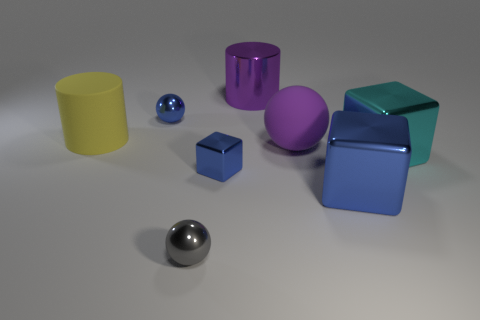Add 2 rubber things. How many objects exist? 10 Subtract all cubes. How many objects are left? 5 Subtract all large cyan rubber balls. Subtract all tiny gray metallic spheres. How many objects are left? 7 Add 2 metal spheres. How many metal spheres are left? 4 Add 8 large cyan matte cylinders. How many large cyan matte cylinders exist? 8 Subtract 1 blue balls. How many objects are left? 7 